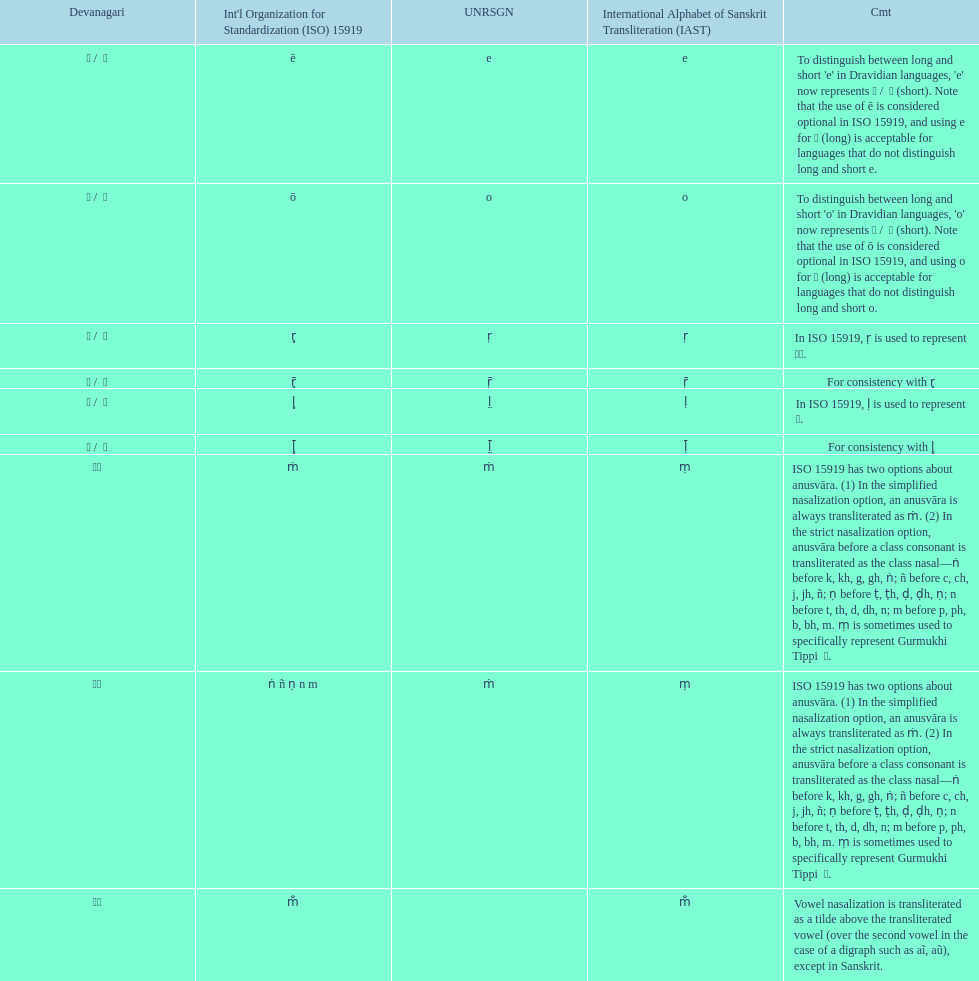Help me parse the entirety of this table. {'header': ['Devanagari', "Int'l Organization for Standardization (ISO) 15919", 'UNRSGN', 'International Alphabet of Sanskrit Transliteration (IAST)', 'Cmt'], 'rows': [['ए / \xa0े', 'ē', 'e', 'e', "To distinguish between long and short 'e' in Dravidian languages, 'e' now represents ऎ / \xa0ॆ (short). Note that the use of ē is considered optional in ISO 15919, and using e for ए (long) is acceptable for languages that do not distinguish long and short e."], ['ओ / \xa0ो', 'ō', 'o', 'o', "To distinguish between long and short 'o' in Dravidian languages, 'o' now represents ऒ / \xa0ॊ (short). Note that the use of ō is considered optional in ISO 15919, and using o for ओ (long) is acceptable for languages that do not distinguish long and short o."], ['ऋ / \xa0ृ', 'r̥', 'ṛ', 'ṛ', 'In ISO 15919, ṛ is used to represent ड़.'], ['ॠ / \xa0ॄ', 'r̥̄', 'ṝ', 'ṝ', 'For consistency with r̥'], ['ऌ / \xa0ॢ', 'l̥', 'l̤', 'ḷ', 'In ISO 15919, ḷ is used to represent ळ.'], ['ॡ / \xa0ॣ', 'l̥̄', 'l̤̄', 'ḹ', 'For consistency with l̥'], ['◌ं', 'ṁ', 'ṁ', 'ṃ', 'ISO 15919 has two options about anusvāra. (1) In the simplified nasalization option, an anusvāra is always transliterated as ṁ. (2) In the strict nasalization option, anusvāra before a class consonant is transliterated as the class nasal—ṅ before k, kh, g, gh, ṅ; ñ before c, ch, j, jh, ñ; ṇ before ṭ, ṭh, ḍ, ḍh, ṇ; n before t, th, d, dh, n; m before p, ph, b, bh, m. ṃ is sometimes used to specifically represent Gurmukhi Tippi \xa0ੰ.'], ['◌ं', 'ṅ ñ ṇ n m', 'ṁ', 'ṃ', 'ISO 15919 has two options about anusvāra. (1) In the simplified nasalization option, an anusvāra is always transliterated as ṁ. (2) In the strict nasalization option, anusvāra before a class consonant is transliterated as the class nasal—ṅ before k, kh, g, gh, ṅ; ñ before c, ch, j, jh, ñ; ṇ before ṭ, ṭh, ḍ, ḍh, ṇ; n before t, th, d, dh, n; m before p, ph, b, bh, m. ṃ is sometimes used to specifically represent Gurmukhi Tippi \xa0ੰ.'], ['◌ँ', 'm̐', '', 'm̐', 'Vowel nasalization is transliterated as a tilde above the transliterated vowel (over the second vowel in the case of a digraph such as aĩ, aũ), except in Sanskrit.']]} Which devanagaria means the same as this iast letter: o? ओ / ो. 